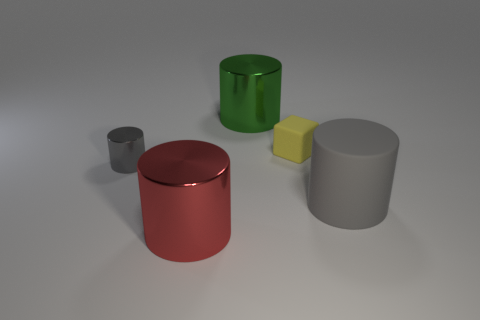There is a metal object that is both behind the gray matte cylinder and in front of the tiny yellow matte thing; what size is it?
Provide a succinct answer. Small. Is the number of tiny metal things less than the number of tiny objects?
Your answer should be compact. Yes. There is a metal cylinder that is right of the red object; what is its size?
Offer a very short reply. Large. What shape is the thing that is left of the green metallic cylinder and behind the big matte thing?
Provide a succinct answer. Cylinder. There is another gray object that is the same shape as the large gray matte object; what is its size?
Your answer should be compact. Small. How many things have the same material as the tiny yellow block?
Provide a short and direct response. 1. Do the large matte cylinder and the tiny object to the left of the red thing have the same color?
Your answer should be compact. Yes. Are there more big yellow matte cubes than red cylinders?
Provide a short and direct response. No. The small block has what color?
Your answer should be compact. Yellow. There is a cylinder on the right side of the green cylinder; does it have the same color as the block?
Your answer should be compact. No. 